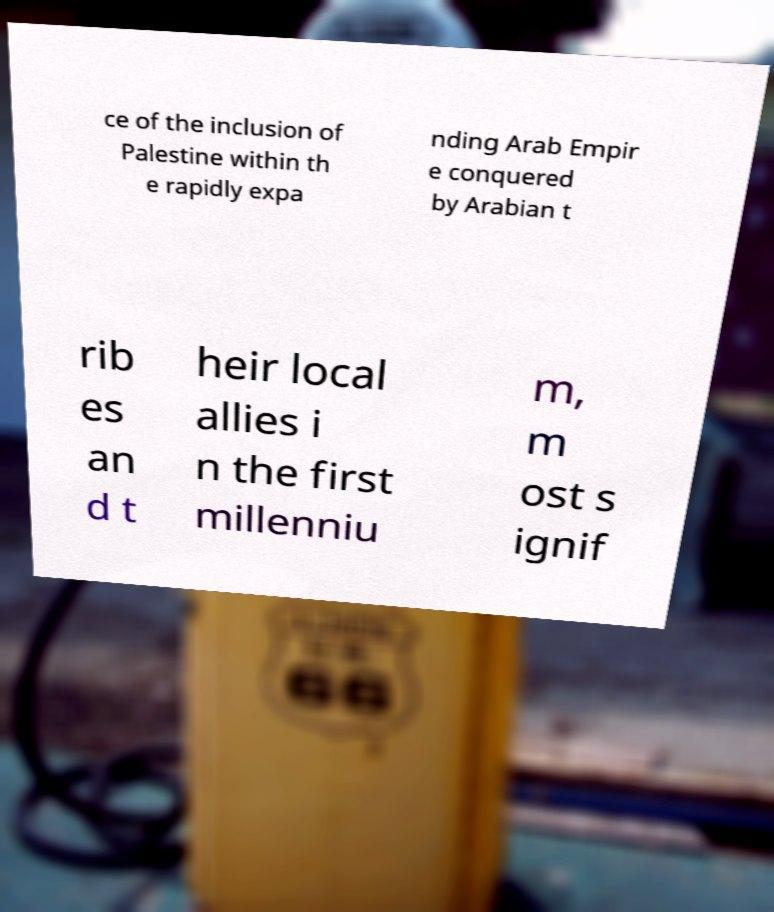Please read and relay the text visible in this image. What does it say? ce of the inclusion of Palestine within th e rapidly expa nding Arab Empir e conquered by Arabian t rib es an d t heir local allies i n the first millenniu m, m ost s ignif 